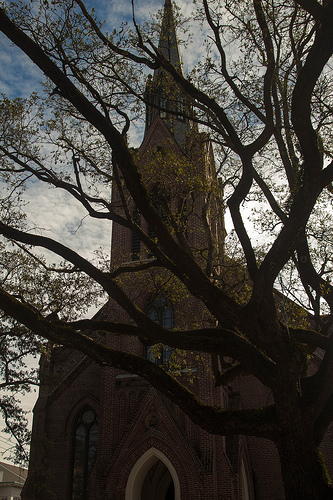<image>
Is there a church behind the tree? Yes. From this viewpoint, the church is positioned behind the tree, with the tree partially or fully occluding the church. 